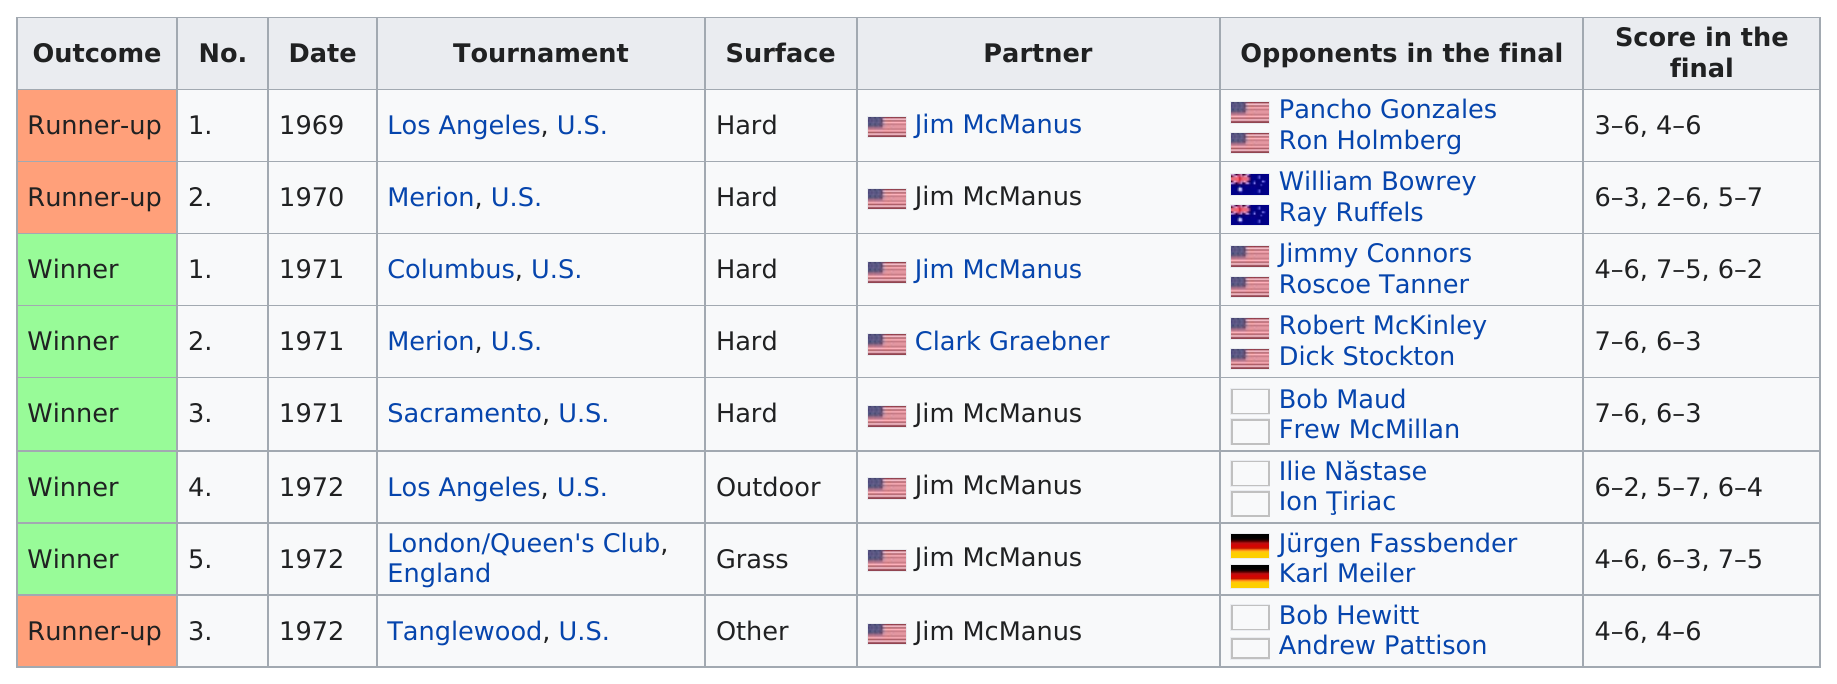Mention a couple of crucial points in this snapshot. The tournament that comes before the one held in 1970 is the Los Angeles tournament, which was held in the United States. The score in the final in 1969 was 3-6, 4-6, and so on. During the open era, Jim Osborne partnered with Jim McManus the most in terms of titles. There were 7 tournaments in which Jim McManus was the partner. The first tennis tournament was held in Los Angeles, United States, marking the beginning of a storied sporting event that is still celebrated to this day. 